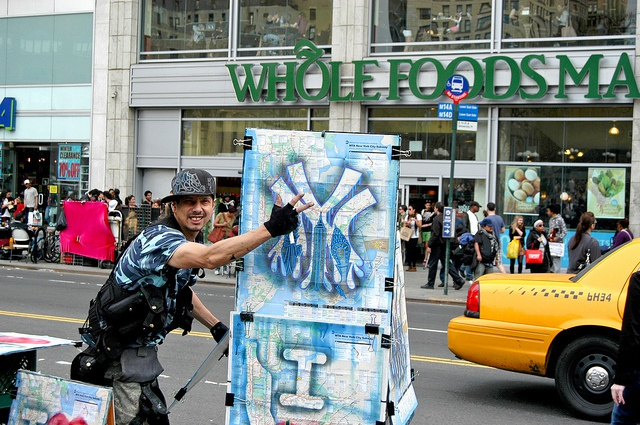Describe the objects in this image and their specific colors. I can see people in lightgray, black, gray, and darkgray tones, people in lightgray, black, gray, and darkgray tones, car in lightgray, gold, black, orange, and red tones, backpack in lightgray, black, gray, and blue tones, and people in lightgray, black, gray, darkgray, and teal tones in this image. 